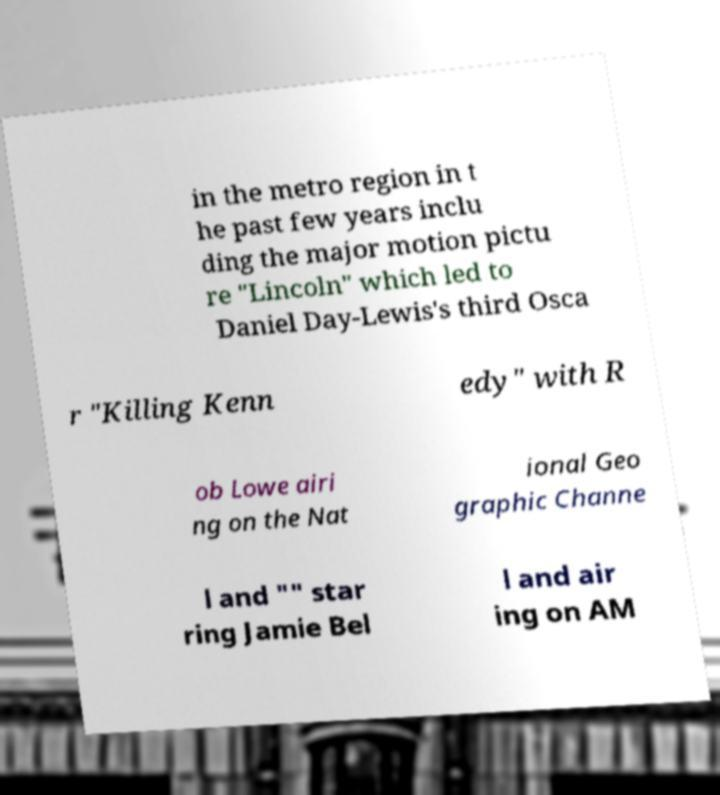Please read and relay the text visible in this image. What does it say? in the metro region in t he past few years inclu ding the major motion pictu re "Lincoln" which led to Daniel Day-Lewis's third Osca r "Killing Kenn edy" with R ob Lowe airi ng on the Nat ional Geo graphic Channe l and "" star ring Jamie Bel l and air ing on AM 